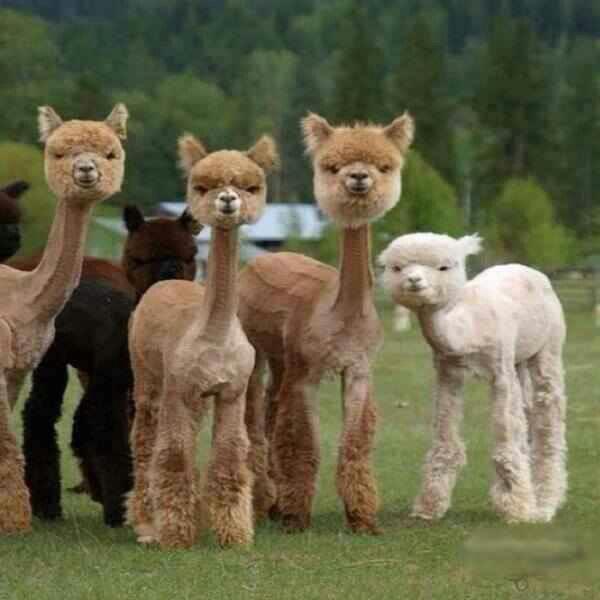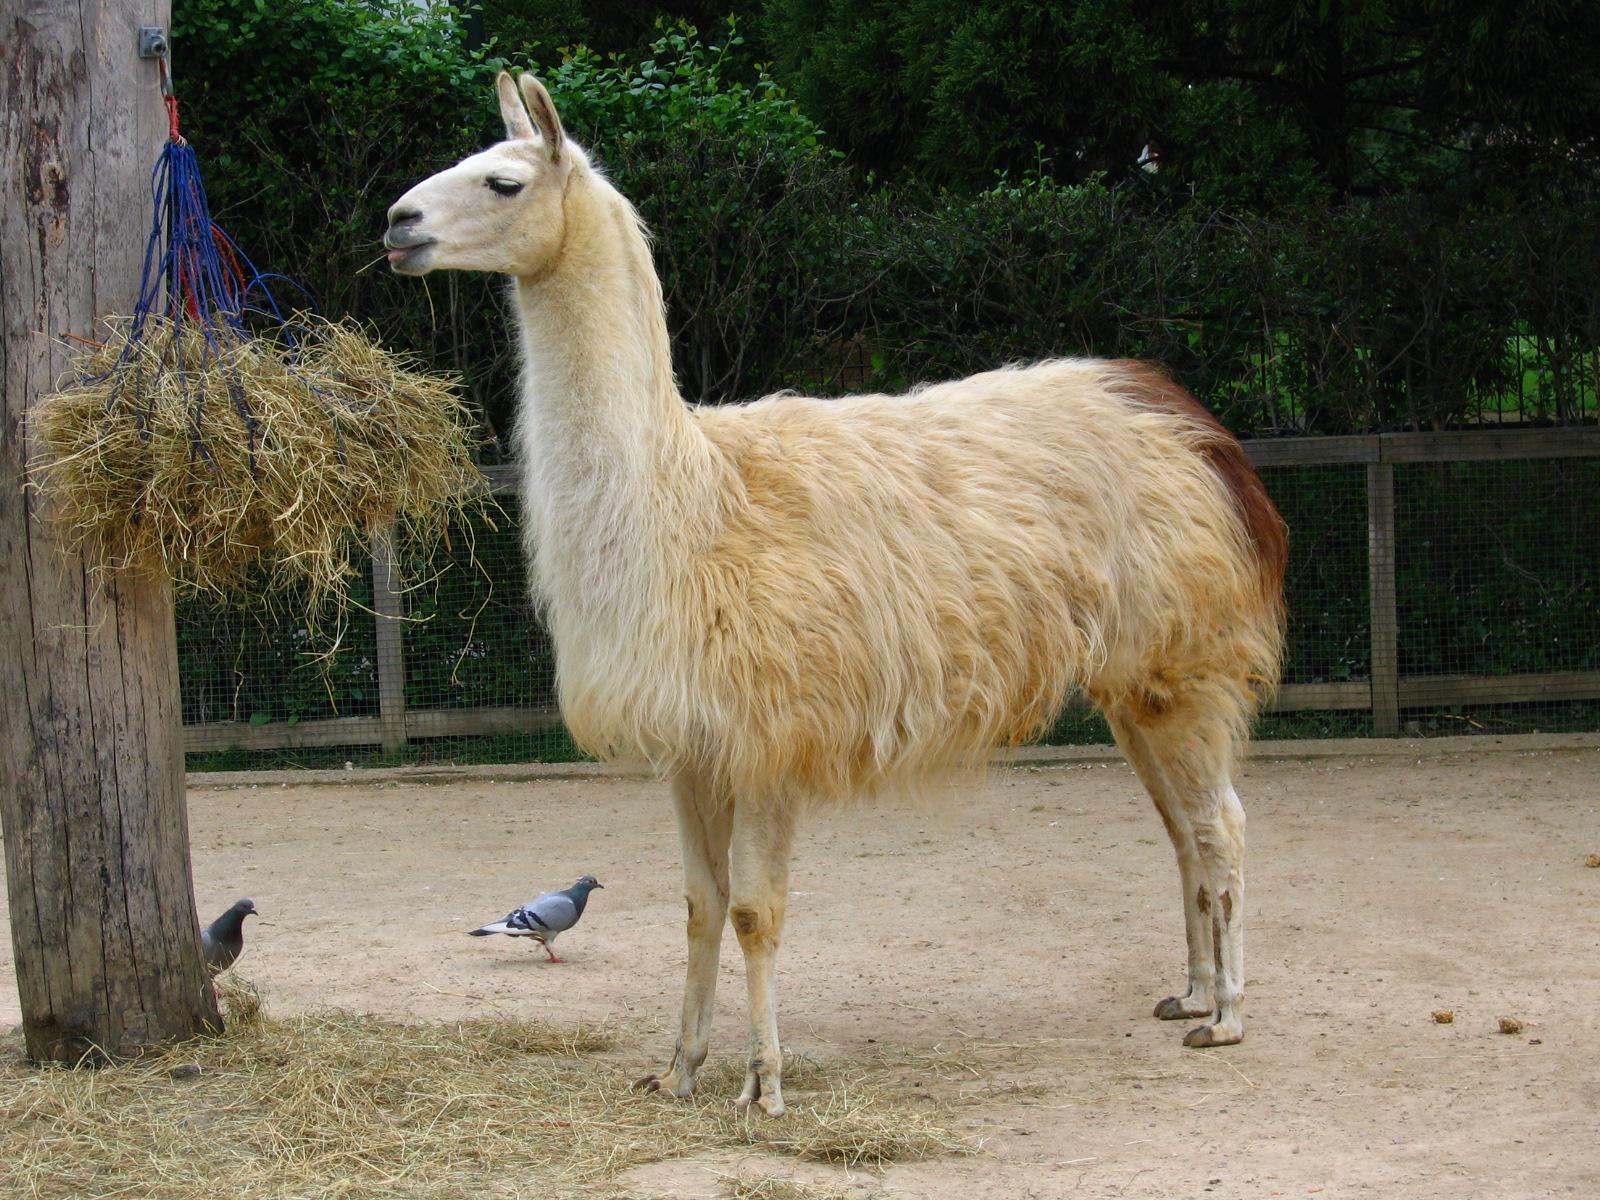The first image is the image on the left, the second image is the image on the right. Considering the images on both sides, is "IN at least one image there are six llamas standing on grass." valid? Answer yes or no. Yes. The first image is the image on the left, the second image is the image on the right. Evaluate the accuracy of this statement regarding the images: "An image shows just one llama, which is standing in profile on dry ground, with its face and body turned the same way.". Is it true? Answer yes or no. Yes. 